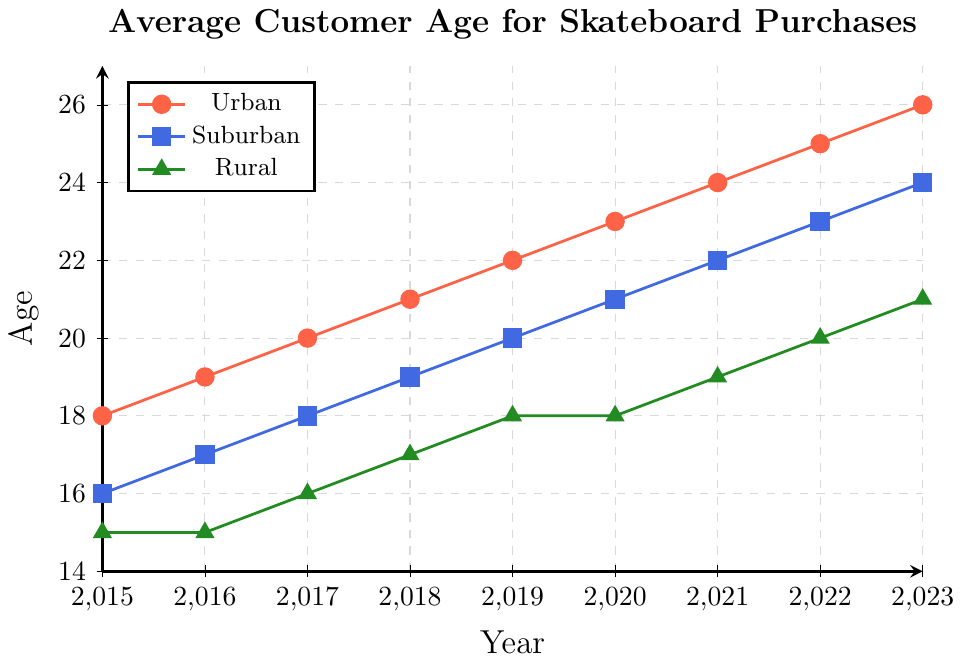When did the Urban location have the youngest average customer age? Refer to the Urban data line, which starts at year 2015 with the age of 18. This is the lowest point on the Urban line.
Answer: 2015 In which year did the Rural location see a significant increase in average customer age? Look for a year-over-year significant increase in the Rural data line. From 2016 to 2017 and 2017 to 2018, the age increases were both by 1. This is consistent, but from 2014 to 2016 the age remains the same.
Answer: 2017 By how many years did the average customer age in the Suburban location increase from 2015 to 2023? The Suburban line starts at 16 in 2015 and ends at 24 in 2023. Subtract 16 from 24 to find the increase.
Answer: 8 years Which location has the steepest average age increase over the period shown? Compare the slope of each line by observing the increase in average customer age from 2015 to 2023 for each location. Urban increases by 8 (26-18), Suburban increases by 8 (24-16), and Rural increases by 6 (21-15). Urban and Suburban have equal steepness.
Answer: Urban and Suburban What was the average customer age in the Rural location in 2020? Refer to the data point for the Rural location for the year 2020, which shows an age of 18.
Answer: 18 Compare the average customer ages in 2019 across different locations. Which location had the highest average age? Look at the data points for 2019: Urban is 22, Suburban is 20, and Rural is 18. The highest value is in the Urban location.
Answer: Urban In which year did Urban and Suburban locations have the same average customer age? Check for any years where the lines for Urban and Suburban data points converge. In this dataset, they don't match in any year shown.
Answer: None How much did the customer age in the Suburban location increase relative to the Urban location from 2015 to 2018? In 2015, Urban is 18 and Suburban is 16, a difference of 2. In 2018, Urban is 21 and Suburban is 19, still a difference of 2. The relative increase was consistent.
Answer: 2 years What's the difference in the average customer age between Urban and Rural locations in 2023? Check the data points for 2023: Urban is 26 and Rural is 21. Subtract 21 from 26.
Answer: 5 years 